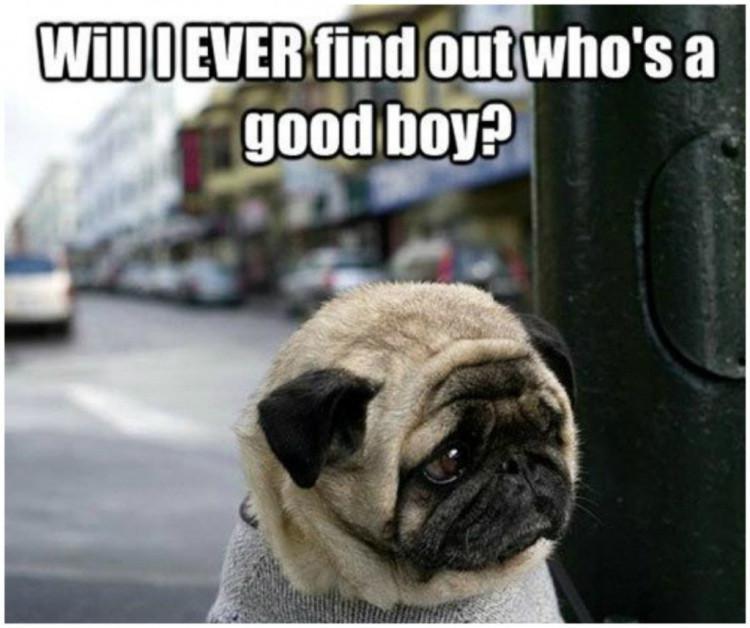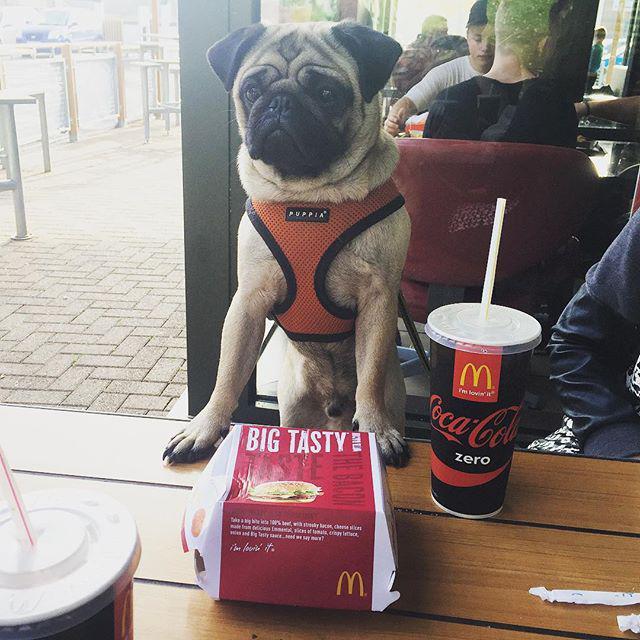The first image is the image on the left, the second image is the image on the right. Analyze the images presented: Is the assertion "Both images show a single pug and in one it has its tongue sticking out." valid? Answer yes or no. No. The first image is the image on the left, the second image is the image on the right. Examine the images to the left and right. Is the description "Each image features one camera-gazing buff-beige pug with a dark muzzle, and one pug has its tongue sticking out." accurate? Answer yes or no. No. 